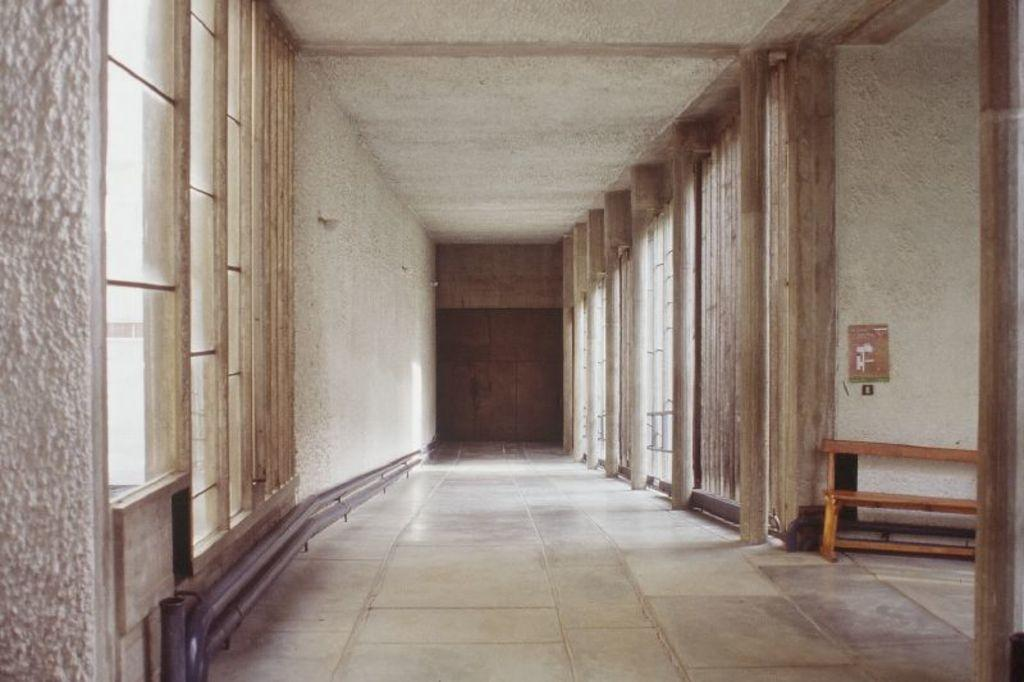What is the main setting of the image? The image consists of a room. What is at the bottom of the room? There is a floor at the bottom of the room. Where are the windows located in the room? There are windows on the left and right sides of the room. What material are the pillars made of in the room? The pillars in the room are made up of wood. What is at the top of the room? There is a roof at the top of the room. Can you hear the geese laughing in the image? There are no geese or sounds of laughter present in the image. 